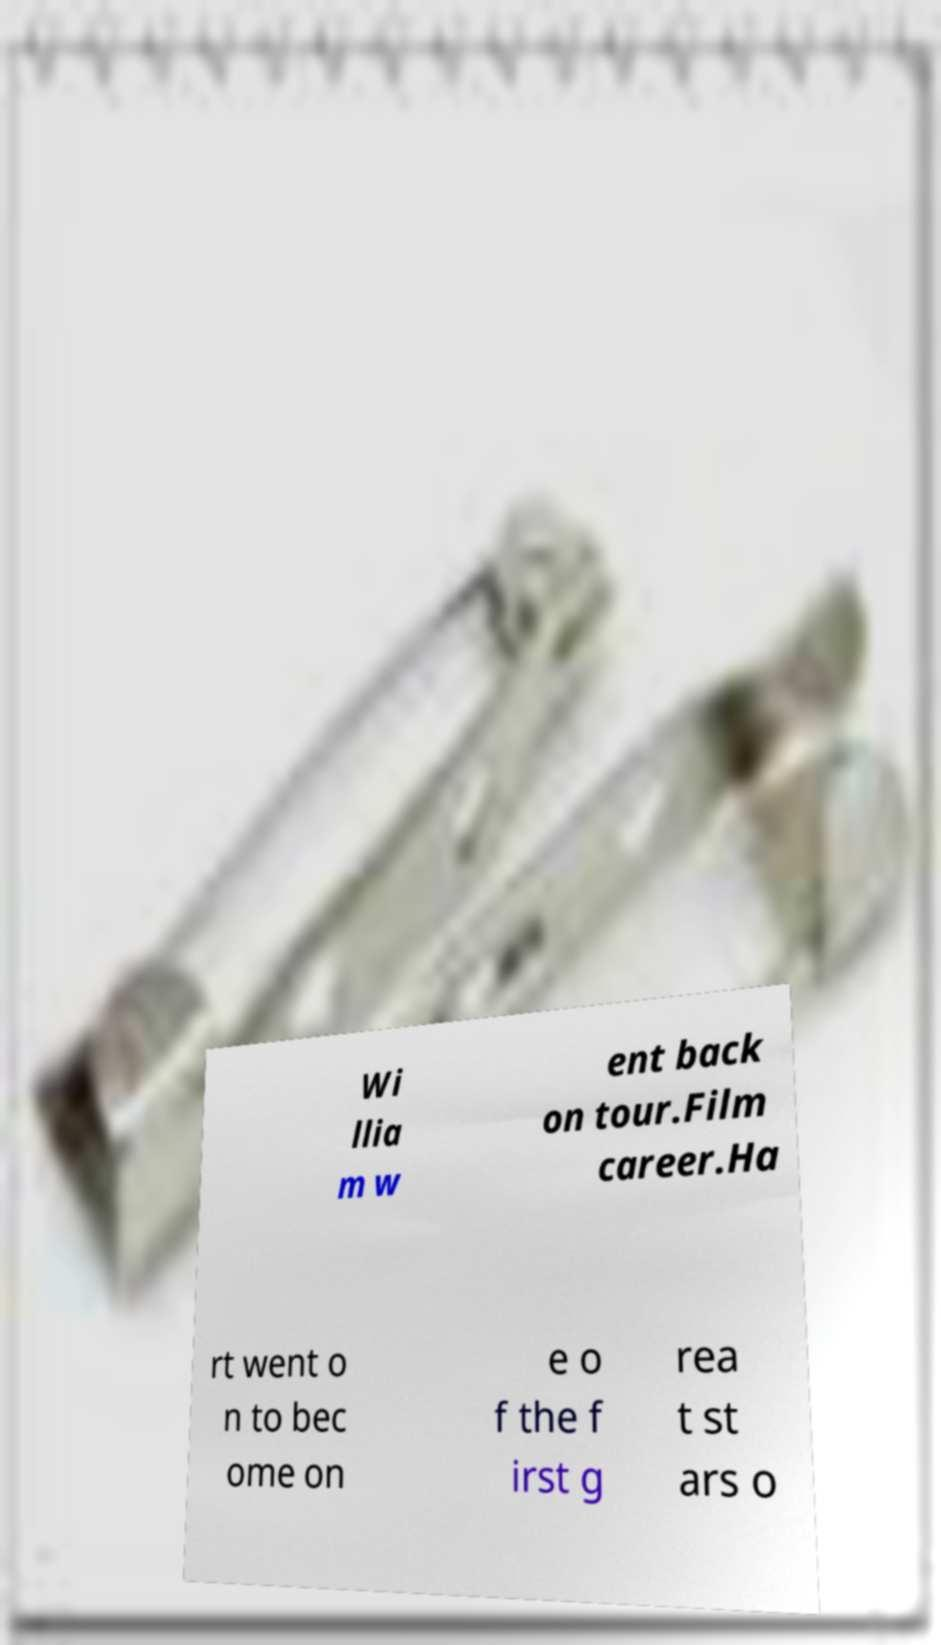Could you extract and type out the text from this image? Wi llia m w ent back on tour.Film career.Ha rt went o n to bec ome on e o f the f irst g rea t st ars o 